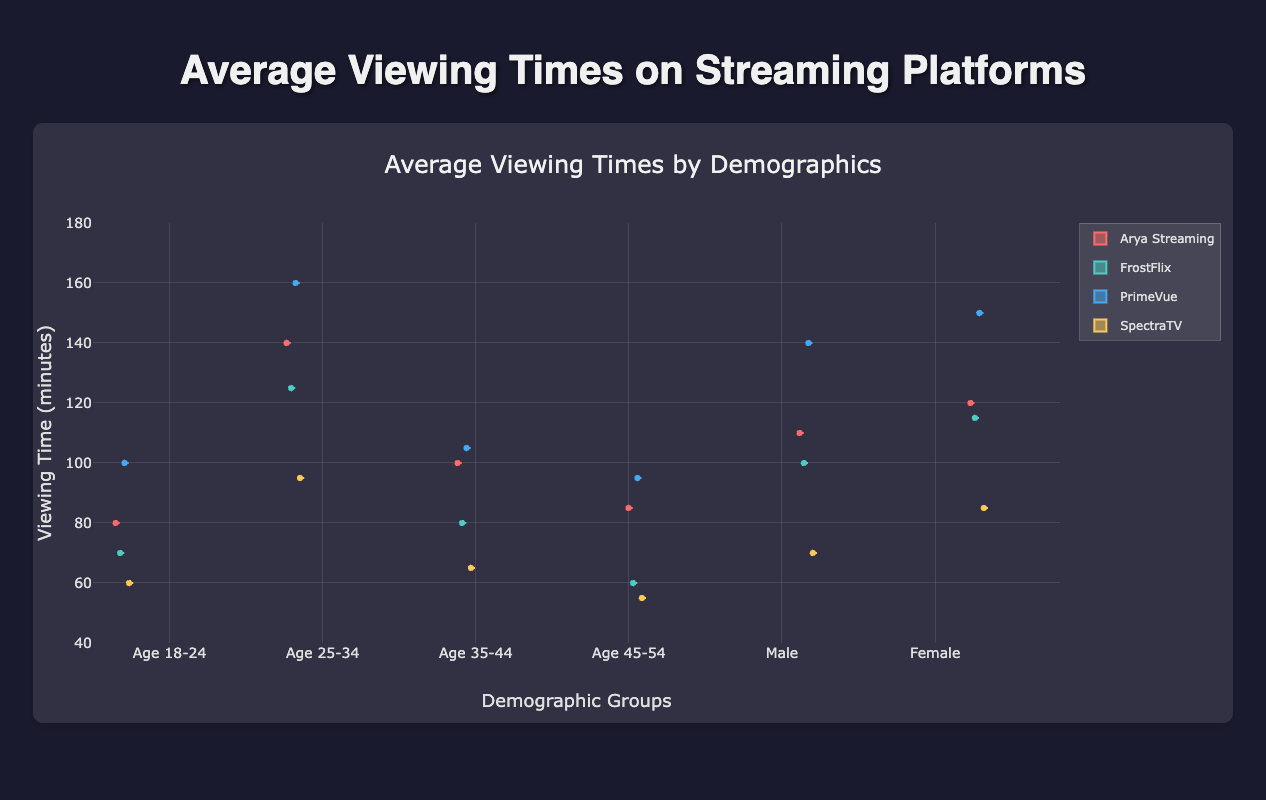What are the four streaming platforms shown in the figure? Look at the legend or the labels on the boxes in the plot. The four platforms are "Arya Streaming," "FrostFlix," "PrimeVue," and "SpectraTV."
Answer: Arya Streaming, FrostFlix, PrimeVue, SpectraTV Which age group has the highest average viewing time for Arya Streaming? Look for the Arya Streaming boxes and observe which age group has the highest median value (represented by the line inside the box). The 25-34 age group has the highest average viewing time for Arya Streaming.
Answer: 25-34 Between males and females, which gender has a higher median viewing time for PrimeVue? Compare the median lines (inside the boxes) for PrimeVue between males and females. The median viewing time for females (represented by the solid line in the box) is higher than that for males.
Answer: Female For the age group 35-44, which streaming platform has the lowest median viewing time? Look at the 35-44 age group's boxes and compare the median lines for all four platforms. SpectraTV has the lowest median viewing time.
Answer: SpectraTV What is the range of viewing times for FrostFlix in the 45-54 age group? The range is determined by the maximum and minimum whiskers of the FrostFlix box in the 45-54 age group. The minimum is 55, and the maximum is 75. Thus, the range is 75 - 55.
Answer: 20 Which age group shows the most variability in viewing times for PrimeVue? The variability is indicated by the interquartile range (IQR), which is the distance between the top and bottom of the box (75th percentile minus the 25th percentile). The 18-24 age group has the widest box for PrimeVue, indicating the most variability.
Answer: 18-24 Do males or females have a wider distribution of viewing times for SpectraTV? A wider distribution is indicated by a larger interquartile range or longer whiskers. Compare the width of the boxes and the length of the whiskers for SpectraTV between males and females. Females have a wider distribution for SpectraTV.
Answer: Female Comparing FrostFlix against SpectraTV for the age group 18-24, which platform has a higher median viewing time? Look at the median lines within the boxes for both FrostFlix and SpectraTV in the 18-24 age group. FrostFlix has a higher median viewing time compared to SpectraTV.
Answer: FrostFlix 